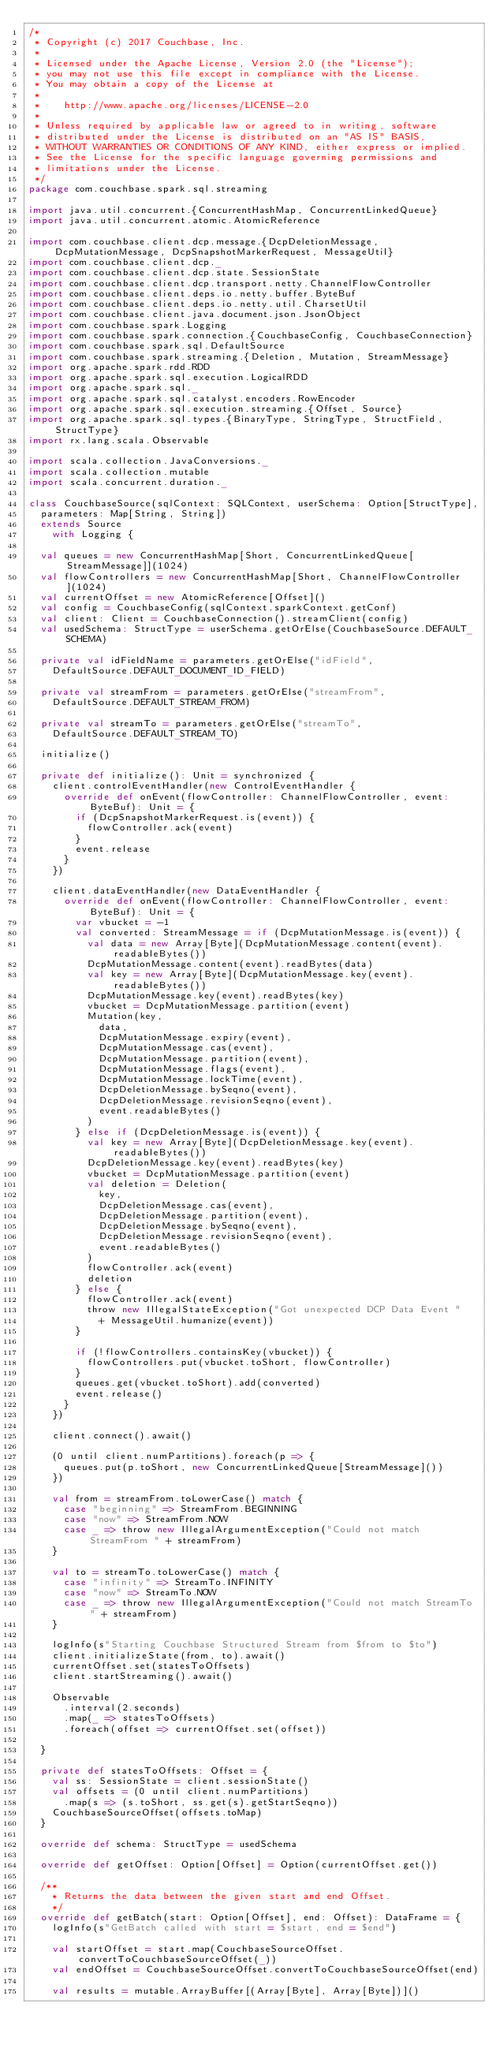Convert code to text. <code><loc_0><loc_0><loc_500><loc_500><_Scala_>/*
 * Copyright (c) 2017 Couchbase, Inc.
 *
 * Licensed under the Apache License, Version 2.0 (the "License");
 * you may not use this file except in compliance with the License.
 * You may obtain a copy of the License at
 *
 *    http://www.apache.org/licenses/LICENSE-2.0
 *
 * Unless required by applicable law or agreed to in writing, software
 * distributed under the License is distributed on an "AS IS" BASIS,
 * WITHOUT WARRANTIES OR CONDITIONS OF ANY KIND, either express or implied.
 * See the License for the specific language governing permissions and
 * limitations under the License.
 */
package com.couchbase.spark.sql.streaming

import java.util.concurrent.{ConcurrentHashMap, ConcurrentLinkedQueue}
import java.util.concurrent.atomic.AtomicReference

import com.couchbase.client.dcp.message.{DcpDeletionMessage, DcpMutationMessage, DcpSnapshotMarkerRequest, MessageUtil}
import com.couchbase.client.dcp._
import com.couchbase.client.dcp.state.SessionState
import com.couchbase.client.dcp.transport.netty.ChannelFlowController
import com.couchbase.client.deps.io.netty.buffer.ByteBuf
import com.couchbase.client.deps.io.netty.util.CharsetUtil
import com.couchbase.client.java.document.json.JsonObject
import com.couchbase.spark.Logging
import com.couchbase.spark.connection.{CouchbaseConfig, CouchbaseConnection}
import com.couchbase.spark.sql.DefaultSource
import com.couchbase.spark.streaming.{Deletion, Mutation, StreamMessage}
import org.apache.spark.rdd.RDD
import org.apache.spark.sql.execution.LogicalRDD
import org.apache.spark.sql._
import org.apache.spark.sql.catalyst.encoders.RowEncoder
import org.apache.spark.sql.execution.streaming.{Offset, Source}
import org.apache.spark.sql.types.{BinaryType, StringType, StructField, StructType}
import rx.lang.scala.Observable

import scala.collection.JavaConversions._
import scala.collection.mutable
import scala.concurrent.duration._

class CouchbaseSource(sqlContext: SQLContext, userSchema: Option[StructType],
  parameters: Map[String, String])
  extends Source
    with Logging {

  val queues = new ConcurrentHashMap[Short, ConcurrentLinkedQueue[StreamMessage]](1024)
  val flowControllers = new ConcurrentHashMap[Short, ChannelFlowController](1024)
  val currentOffset = new AtomicReference[Offset]()
  val config = CouchbaseConfig(sqlContext.sparkContext.getConf)
  val client: Client = CouchbaseConnection().streamClient(config)
  val usedSchema: StructType = userSchema.getOrElse(CouchbaseSource.DEFAULT_SCHEMA)

  private val idFieldName = parameters.getOrElse("idField",
    DefaultSource.DEFAULT_DOCUMENT_ID_FIELD)

  private val streamFrom = parameters.getOrElse("streamFrom",
    DefaultSource.DEFAULT_STREAM_FROM)

  private val streamTo = parameters.getOrElse("streamTo",
    DefaultSource.DEFAULT_STREAM_TO)

  initialize()

  private def initialize(): Unit = synchronized {
    client.controlEventHandler(new ControlEventHandler {
      override def onEvent(flowController: ChannelFlowController, event: ByteBuf): Unit = {
        if (DcpSnapshotMarkerRequest.is(event)) {
          flowController.ack(event)
        }
        event.release
      }
    })

    client.dataEventHandler(new DataEventHandler {
      override def onEvent(flowController: ChannelFlowController, event: ByteBuf): Unit = {
        var vbucket = -1
        val converted: StreamMessage = if (DcpMutationMessage.is(event)) {
          val data = new Array[Byte](DcpMutationMessage.content(event).readableBytes())
          DcpMutationMessage.content(event).readBytes(data)
          val key = new Array[Byte](DcpMutationMessage.key(event).readableBytes())
          DcpMutationMessage.key(event).readBytes(key)
          vbucket = DcpMutationMessage.partition(event)
          Mutation(key,
            data,
            DcpMutationMessage.expiry(event),
            DcpMutationMessage.cas(event),
            DcpMutationMessage.partition(event),
            DcpMutationMessage.flags(event),
            DcpMutationMessage.lockTime(event),
            DcpDeletionMessage.bySeqno(event),
            DcpDeletionMessage.revisionSeqno(event),
            event.readableBytes()
          )
        } else if (DcpDeletionMessage.is(event)) {
          val key = new Array[Byte](DcpDeletionMessage.key(event).readableBytes())
          DcpDeletionMessage.key(event).readBytes(key)
          vbucket = DcpMutationMessage.partition(event)
          val deletion = Deletion(
            key,
            DcpDeletionMessage.cas(event),
            DcpDeletionMessage.partition(event),
            DcpDeletionMessage.bySeqno(event),
            DcpDeletionMessage.revisionSeqno(event),
            event.readableBytes()
          )
          flowController.ack(event)
          deletion
        } else {
          flowController.ack(event)
          throw new IllegalStateException("Got unexpected DCP Data Event "
            + MessageUtil.humanize(event))
        }

        if (!flowControllers.containsKey(vbucket)) {
          flowControllers.put(vbucket.toShort, flowController)
        }
        queues.get(vbucket.toShort).add(converted)
        event.release()
      }
    })

    client.connect().await()

    (0 until client.numPartitions).foreach(p => {
      queues.put(p.toShort, new ConcurrentLinkedQueue[StreamMessage]())
    })

    val from = streamFrom.toLowerCase() match {
      case "beginning" => StreamFrom.BEGINNING
      case "now" => StreamFrom.NOW
      case _ => throw new IllegalArgumentException("Could not match StreamFrom " + streamFrom)
    }

    val to = streamTo.toLowerCase() match {
      case "infinity" => StreamTo.INFINITY
      case "now" => StreamTo.NOW
      case _ => throw new IllegalArgumentException("Could not match StreamTo " + streamFrom)
    }

    logInfo(s"Starting Couchbase Structured Stream from $from to $to")
    client.initializeState(from, to).await()
    currentOffset.set(statesToOffsets)
    client.startStreaming().await()

    Observable
      .interval(2.seconds)
      .map(_ => statesToOffsets)
      .foreach(offset => currentOffset.set(offset))

  }

  private def statesToOffsets: Offset = {
    val ss: SessionState = client.sessionState()
    val offsets = (0 until client.numPartitions)
      .map(s => (s.toShort, ss.get(s).getStartSeqno))
    CouchbaseSourceOffset(offsets.toMap)
  }

  override def schema: StructType = usedSchema

  override def getOffset: Option[Offset] = Option(currentOffset.get())

  /**
    * Returns the data between the given start and end Offset.
    */
  override def getBatch(start: Option[Offset], end: Offset): DataFrame = {
    logInfo(s"GetBatch called with start = $start, end = $end")

    val startOffset = start.map(CouchbaseSourceOffset.convertToCouchbaseSourceOffset(_))
    val endOffset = CouchbaseSourceOffset.convertToCouchbaseSourceOffset(end)

    val results = mutable.ArrayBuffer[(Array[Byte], Array[Byte])]()
</code> 